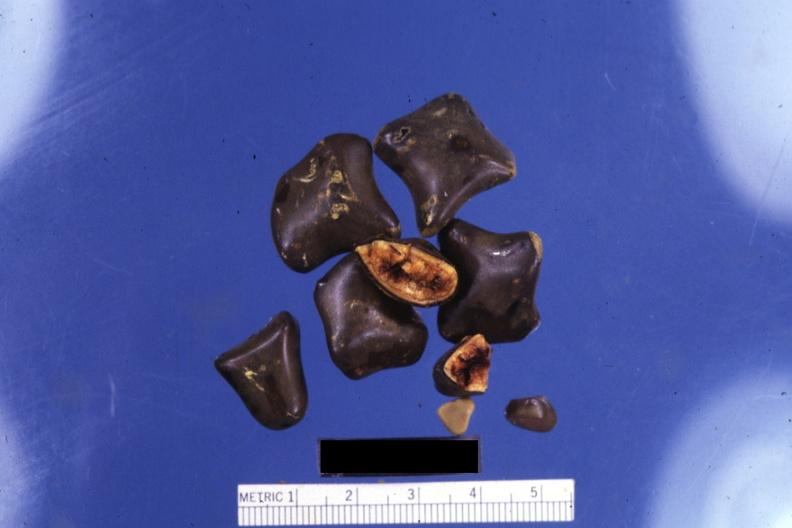what is close-up of faceted mixed stones with two showing?
Answer the question using a single word or phrase. Two showing cut surfaces 